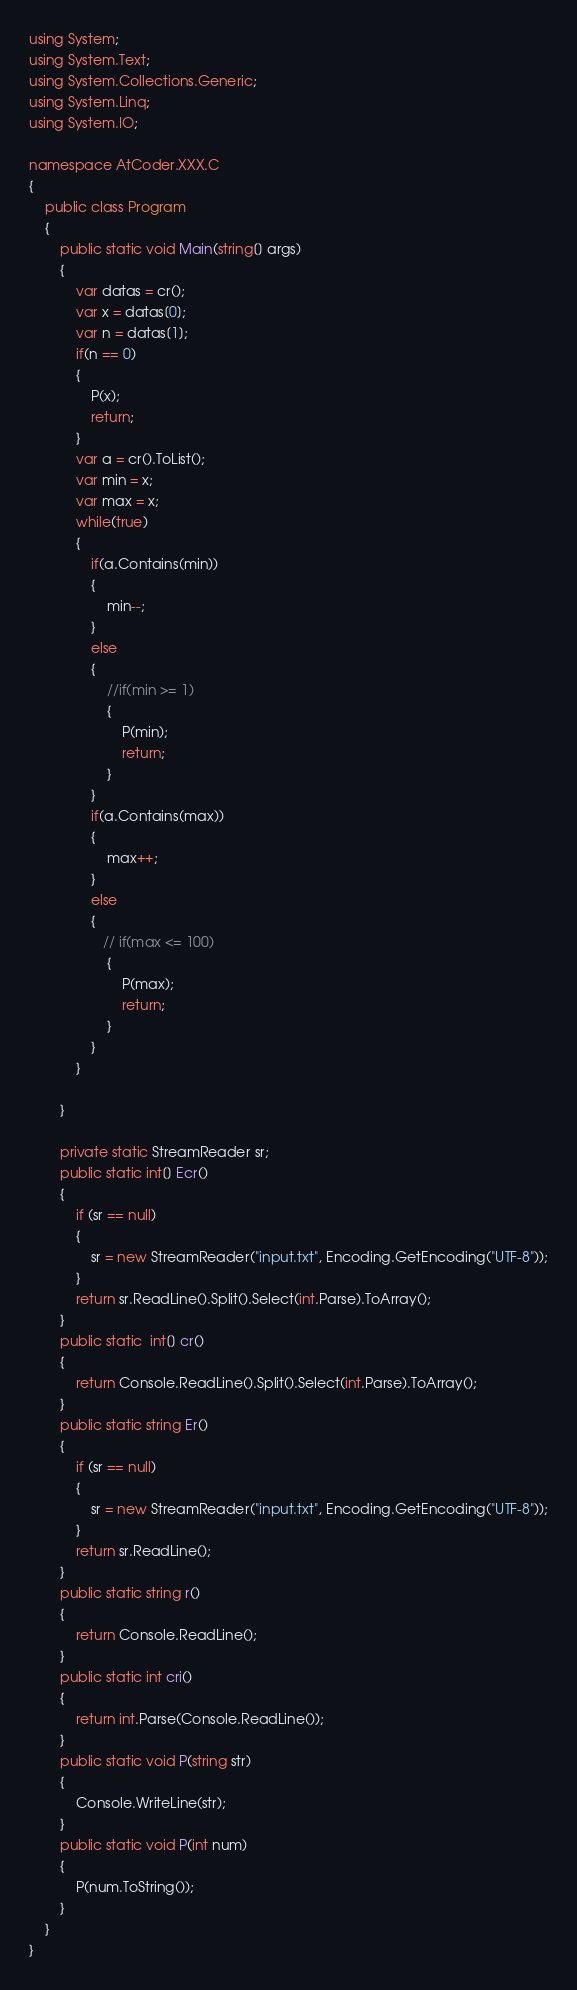<code> <loc_0><loc_0><loc_500><loc_500><_C#_>using System;
using System.Text;
using System.Collections.Generic;
using System.Linq;
using System.IO;

namespace AtCoder.XXX.C
{ 
    public class Program
    {
        public static void Main(string[] args)
        {
            var datas = cr();
            var x = datas[0];
            var n = datas[1];
            if(n == 0)
			{
                P(x);
                return;
			}
            var a = cr().ToList();
            var min = x;
            var max = x;
            while(true)
			{
                if(a.Contains(min))
				{
                    min--;
				}
				else
				{
                    //if(min >= 1)
					{
                        P(min);
                        return;
                    }   
				}
                if(a.Contains(max))
				{
                    max++;
				}
				else
				{
                   // if(max <= 100)
					{
                        P(max);
                        return;
                    }
				}
			}

        }

        private static StreamReader sr;
        public static int[] Ecr()
        {
            if (sr == null)
            {
                sr = new StreamReader("input.txt", Encoding.GetEncoding("UTF-8"));
            }
            return sr.ReadLine().Split().Select(int.Parse).ToArray();
        }
        public static  int[] cr()
        {
            return Console.ReadLine().Split().Select(int.Parse).ToArray();
        }
        public static string Er()
        {
            if (sr == null)
            {
                sr = new StreamReader("input.txt", Encoding.GetEncoding("UTF-8"));
            }
            return sr.ReadLine();
        }
        public static string r()
        {
            return Console.ReadLine();
        }
        public static int cri()
        {
            return int.Parse(Console.ReadLine());
        }
        public static void P(string str)
        {
            Console.WriteLine(str);
        }
        public static void P(int num)
        {
            P(num.ToString());
        }
    }
}
</code> 